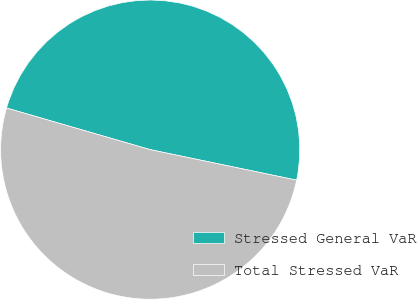<chart> <loc_0><loc_0><loc_500><loc_500><pie_chart><fcel>Stressed General VaR<fcel>Total Stressed VaR<nl><fcel>48.78%<fcel>51.22%<nl></chart> 